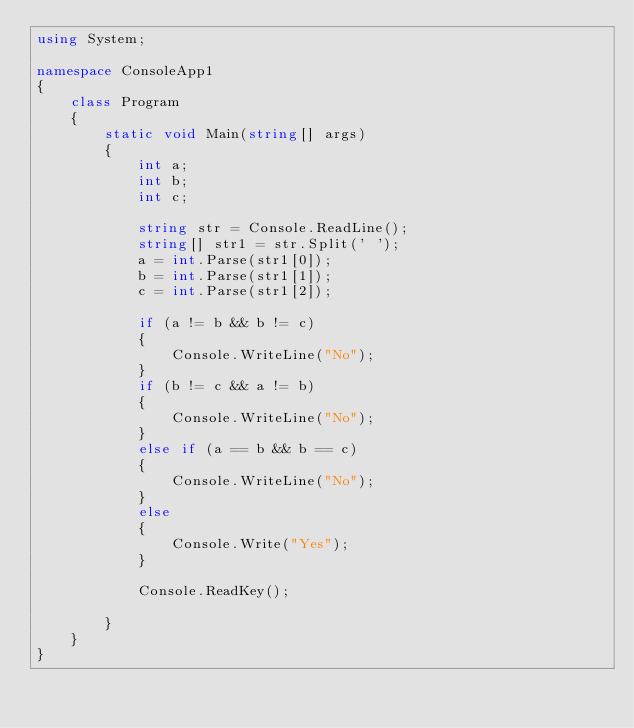Convert code to text. <code><loc_0><loc_0><loc_500><loc_500><_C#_>using System;

namespace ConsoleApp1
{
    class Program
    {
        static void Main(string[] args)
        {
            int a;
            int b;
            int c;

            string str = Console.ReadLine();
            string[] str1 = str.Split(' ');
            a = int.Parse(str1[0]);
            b = int.Parse(str1[1]);
            c = int.Parse(str1[2]);

            if (a != b && b != c)
            {
                Console.WriteLine("No");
            }
            if (b != c && a != b)
            {
                Console.WriteLine("No");
            }
            else if (a == b && b == c)
            {
                Console.WriteLine("No");
            }
            else
            {
                Console.Write("Yes");
            }

            Console.ReadKey();

        }
    }
}
</code> 